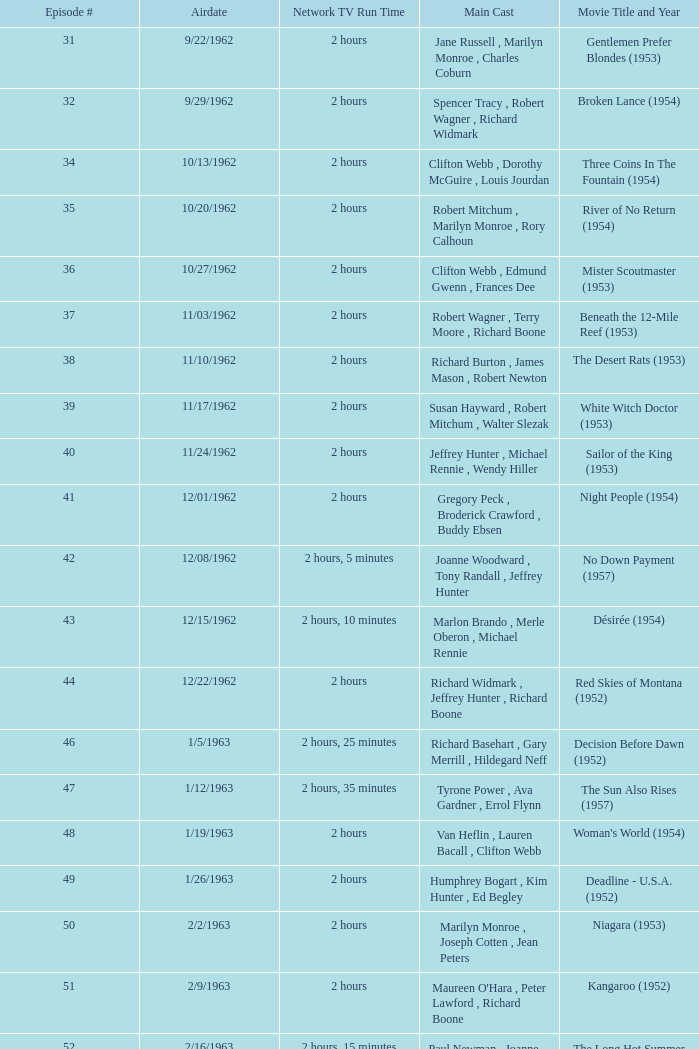How many runtimes does episode 53 have? 1.0. 